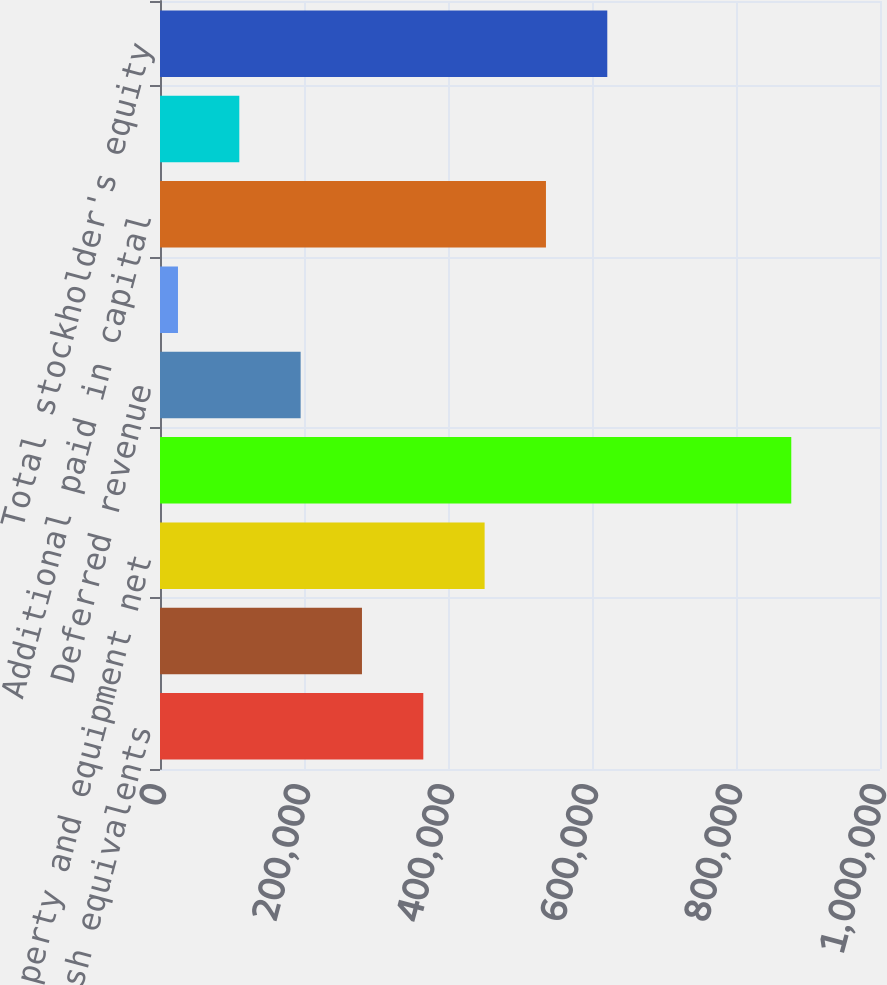Convert chart. <chart><loc_0><loc_0><loc_500><loc_500><bar_chart><fcel>Cash and cash equivalents<fcel>Working capital (deficit) (3)<fcel>Property and equipment net<fcel>Total assets<fcel>Deferred revenue<fcel>Long-term debt less current<fcel>Additional paid in capital<fcel>Retained earnings (accumulated<fcel>Total stockholder's equity<nl><fcel>365694<fcel>280514<fcel>450874<fcel>876773<fcel>195334<fcel>24974<fcel>536053<fcel>110154<fcel>621233<nl></chart> 